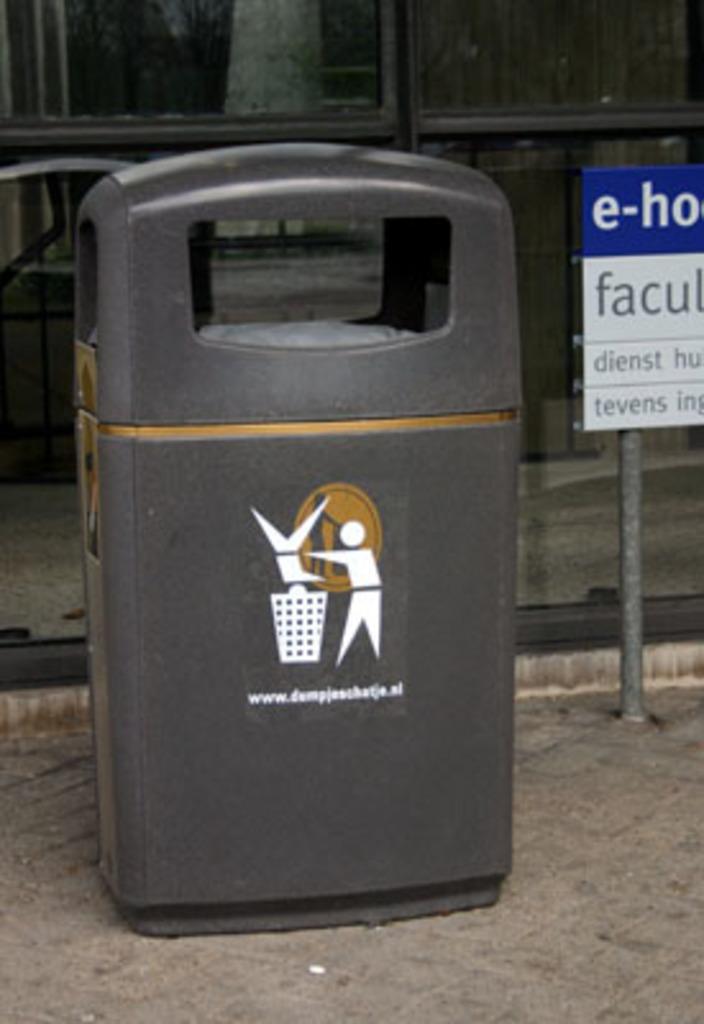Could you give a brief overview of what you see in this image? In this image, we can see a black dustbin with figure and text is placed on the walkway. Right side of the image, there is a pole with board. Background we can see glass objects and walkway. 